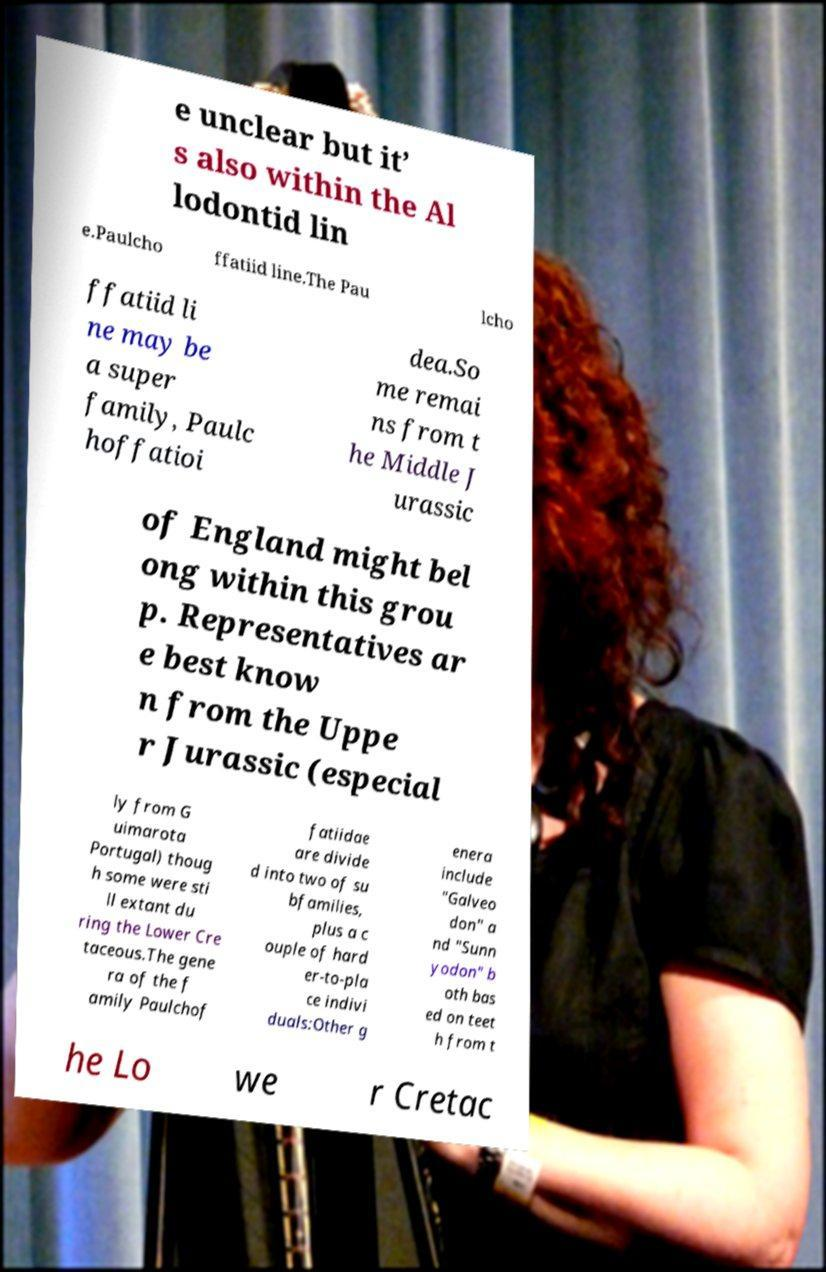For documentation purposes, I need the text within this image transcribed. Could you provide that? e unclear but it’ s also within the Al lodontid lin e.Paulcho ffatiid line.The Pau lcho ffatiid li ne may be a super family, Paulc hoffatioi dea.So me remai ns from t he Middle J urassic of England might bel ong within this grou p. Representatives ar e best know n from the Uppe r Jurassic (especial ly from G uimarota Portugal) thoug h some were sti ll extant du ring the Lower Cre taceous.The gene ra of the f amily Paulchof fatiidae are divide d into two of su bfamilies, plus a c ouple of hard er-to-pla ce indivi duals:Other g enera include "Galveo don" a nd "Sunn yodon" b oth bas ed on teet h from t he Lo we r Cretac 